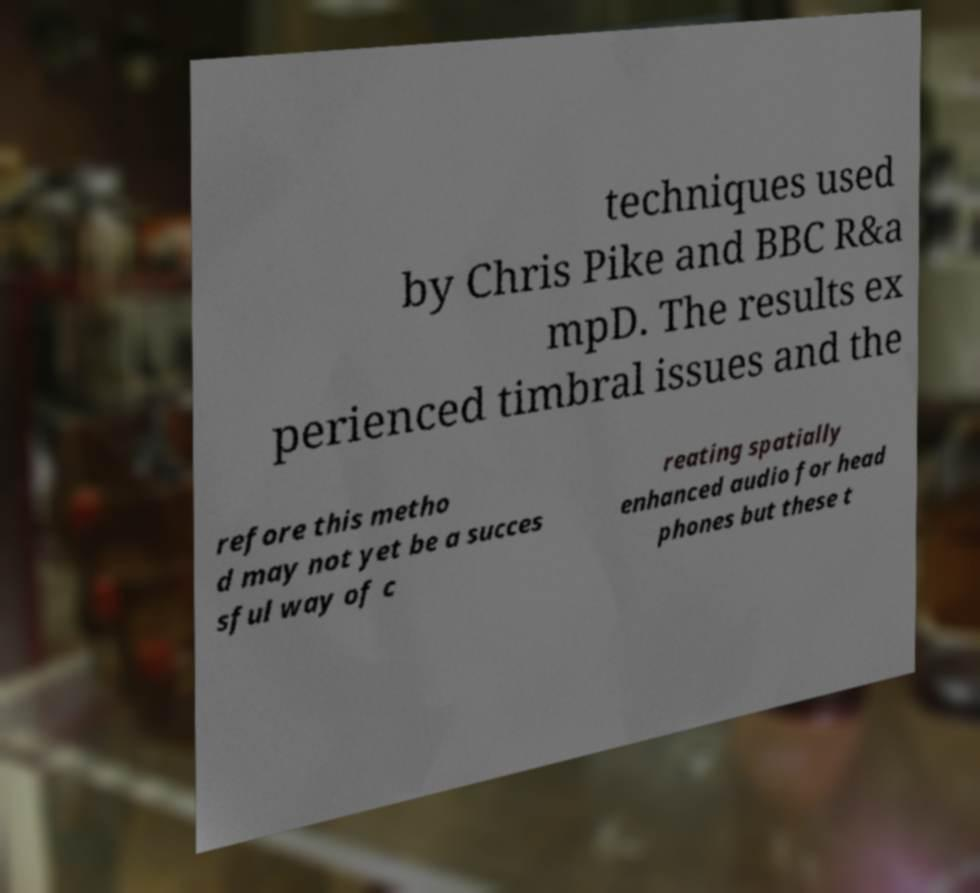Please identify and transcribe the text found in this image. techniques used by Chris Pike and BBC R&a mpD. The results ex perienced timbral issues and the refore this metho d may not yet be a succes sful way of c reating spatially enhanced audio for head phones but these t 